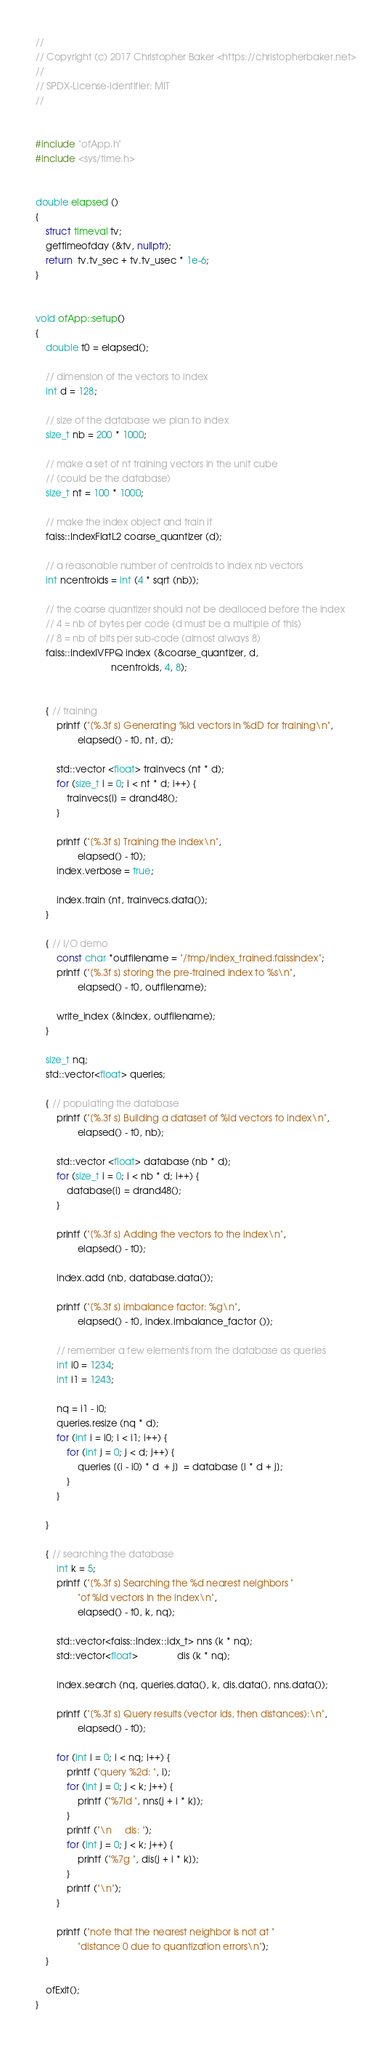Convert code to text. <code><loc_0><loc_0><loc_500><loc_500><_C++_>//
// Copyright (c) 2017 Christopher Baker <https://christopherbaker.net>
//
// SPDX-License-Identifier:	MIT
//


#include "ofApp.h"
#include <sys/time.h>


double elapsed ()
{
    struct timeval tv;
    gettimeofday (&tv, nullptr);
    return  tv.tv_sec + tv.tv_usec * 1e-6;
}


void ofApp::setup()
{
    double t0 = elapsed();
    
    // dimension of the vectors to index
    int d = 128;
    
    // size of the database we plan to index
    size_t nb = 200 * 1000;
    
    // make a set of nt training vectors in the unit cube
    // (could be the database)
    size_t nt = 100 * 1000;
    
    // make the index object and train it
    faiss::IndexFlatL2 coarse_quantizer (d);
    
    // a reasonable number of centroids to index nb vectors
    int ncentroids = int (4 * sqrt (nb));
    
    // the coarse quantizer should not be dealloced before the index
    // 4 = nb of bytes per code (d must be a multiple of this)
    // 8 = nb of bits per sub-code (almost always 8)
    faiss::IndexIVFPQ index (&coarse_quantizer, d,
                             ncentroids, 4, 8);
    
    
    { // training
        printf ("[%.3f s] Generating %ld vectors in %dD for training\n",
                elapsed() - t0, nt, d);
        
        std::vector <float> trainvecs (nt * d);
        for (size_t i = 0; i < nt * d; i++) {
            trainvecs[i] = drand48();
        }
        
        printf ("[%.3f s] Training the index\n",
                elapsed() - t0);
        index.verbose = true;
        
        index.train (nt, trainvecs.data());
    }
    
    { // I/O demo
        const char *outfilename = "/tmp/index_trained.faissindex";
        printf ("[%.3f s] storing the pre-trained index to %s\n",
                elapsed() - t0, outfilename);
        
        write_index (&index, outfilename);
    }
    
    size_t nq;
    std::vector<float> queries;
    
    { // populating the database
        printf ("[%.3f s] Building a dataset of %ld vectors to index\n",
                elapsed() - t0, nb);
        
        std::vector <float> database (nb * d);
        for (size_t i = 0; i < nb * d; i++) {
            database[i] = drand48();
        }
        
        printf ("[%.3f s] Adding the vectors to the index\n",
                elapsed() - t0);
        
        index.add (nb, database.data());
        
        printf ("[%.3f s] imbalance factor: %g\n",
                elapsed() - t0, index.imbalance_factor ());
        
        // remember a few elements from the database as queries
        int i0 = 1234;
        int i1 = 1243;
        
        nq = i1 - i0;
        queries.resize (nq * d);
        for (int i = i0; i < i1; i++) {
            for (int j = 0; j < d; j++) {
                queries [(i - i0) * d  + j]  = database [i * d + j];
            }
        }
        
    }
    
    { // searching the database
        int k = 5;
        printf ("[%.3f s] Searching the %d nearest neighbors "
                "of %ld vectors in the index\n",
                elapsed() - t0, k, nq);
        
        std::vector<faiss::Index::idx_t> nns (k * nq);
        std::vector<float>               dis (k * nq);
        
        index.search (nq, queries.data(), k, dis.data(), nns.data());
        
        printf ("[%.3f s] Query results (vector ids, then distances):\n",
                elapsed() - t0);
        
        for (int i = 0; i < nq; i++) {
            printf ("query %2d: ", i);
            for (int j = 0; j < k; j++) {
                printf ("%7ld ", nns[j + i * k]);
            }
            printf ("\n     dis: ");
            for (int j = 0; j < k; j++) {
                printf ("%7g ", dis[j + i * k]);
            }
            printf ("\n");
        }
        
        printf ("note that the nearest neighbor is not at "
                "distance 0 due to quantization errors\n");
    }

    ofExit();
}
</code> 